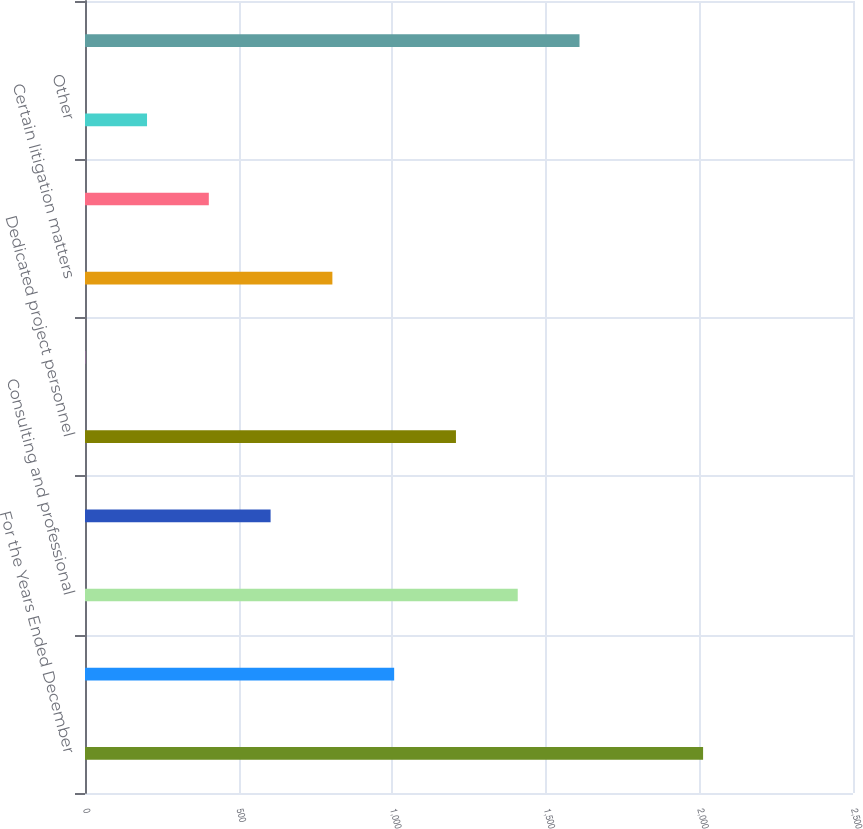Convert chart to OTSL. <chart><loc_0><loc_0><loc_500><loc_500><bar_chart><fcel>For the Years Ended December<fcel>Impairment/loss on disposal of<fcel>Consulting and professional<fcel>Employee severance and<fcel>Dedicated project personnel<fcel>Distributor acquisitions<fcel>Certain litigation matters<fcel>Contract terminations<fcel>Other<fcel>Special items<nl><fcel>2012<fcel>1006.4<fcel>1408.64<fcel>604.16<fcel>1207.52<fcel>0.8<fcel>805.28<fcel>403.04<fcel>201.92<fcel>1609.76<nl></chart> 